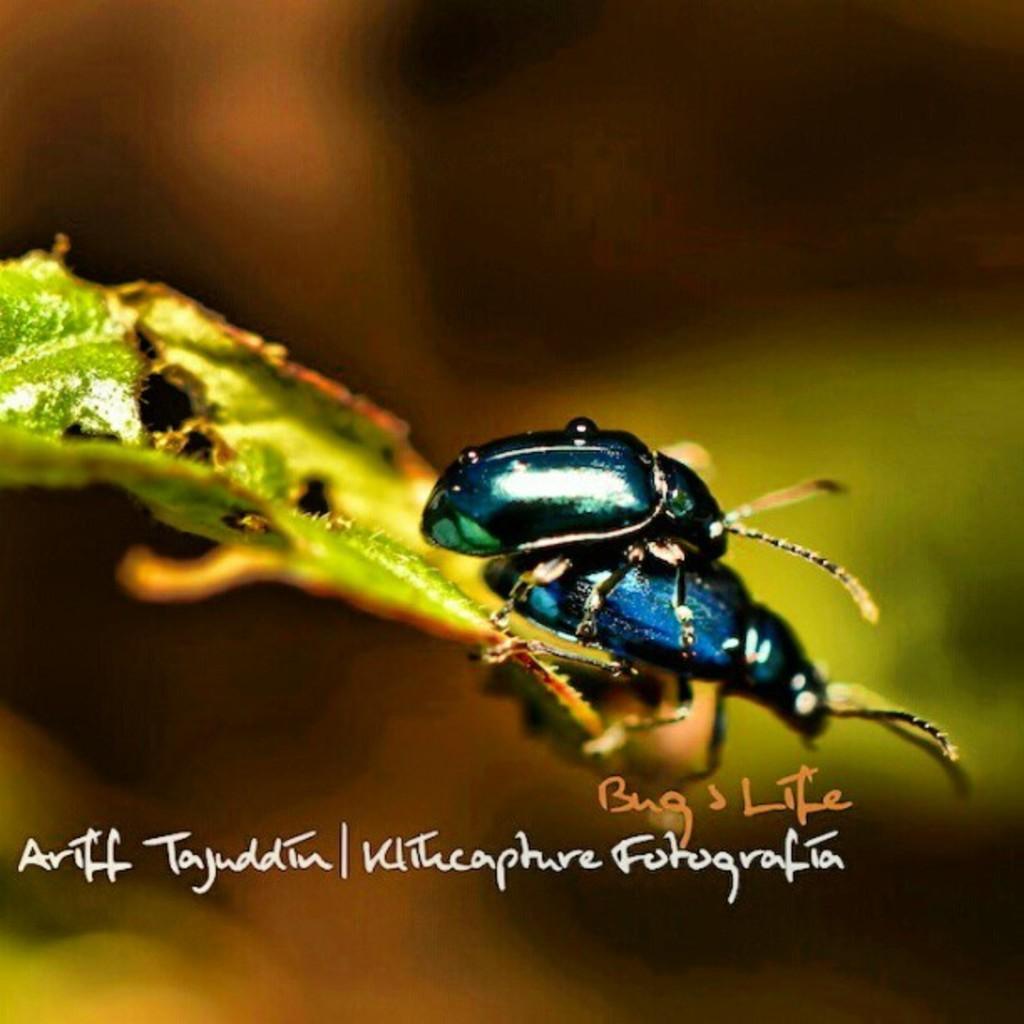How would you summarize this image in a sentence or two? In the picture we can see an insect which is black in color on another insect which is some blue and black in color on the leaf which is green in color, and some wordings beside it as bug's life. 